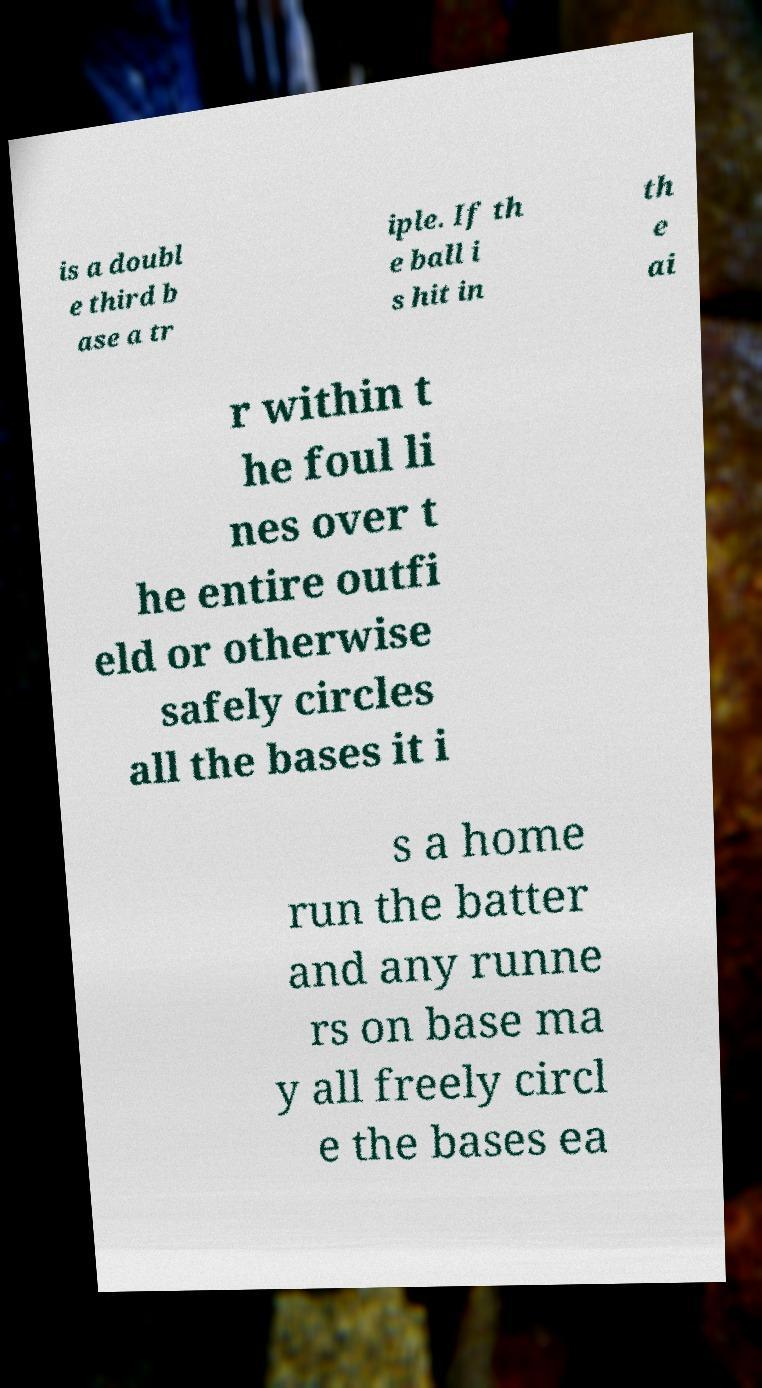Could you assist in decoding the text presented in this image and type it out clearly? is a doubl e third b ase a tr iple. If th e ball i s hit in th e ai r within t he foul li nes over t he entire outfi eld or otherwise safely circles all the bases it i s a home run the batter and any runne rs on base ma y all freely circl e the bases ea 